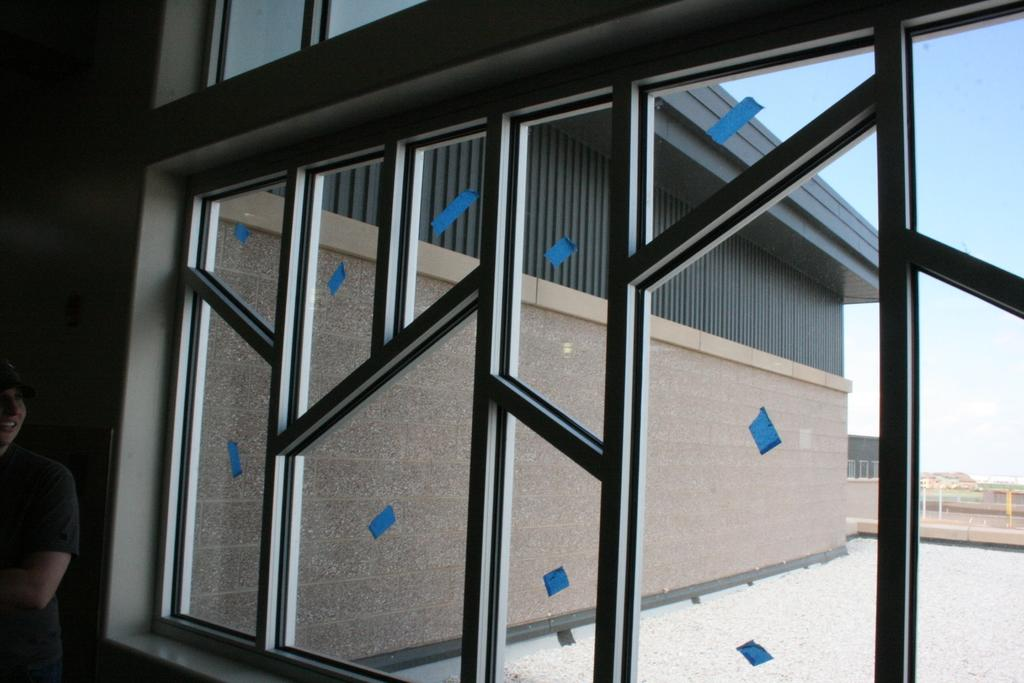What type of structure is present in the image? There is a glass window in the image, which is part of a building. What can be seen outside the window? Houses and a fence are visible outside the window. What is visible at the top of the image? The sky is visible at the top of the image. Can you describe the person standing near the window? There is a person standing to the left of the window. What type of lunch is being prepared in the image? There is no indication of lunch preparation in the image; it primarily features a glass window and its surroundings. 